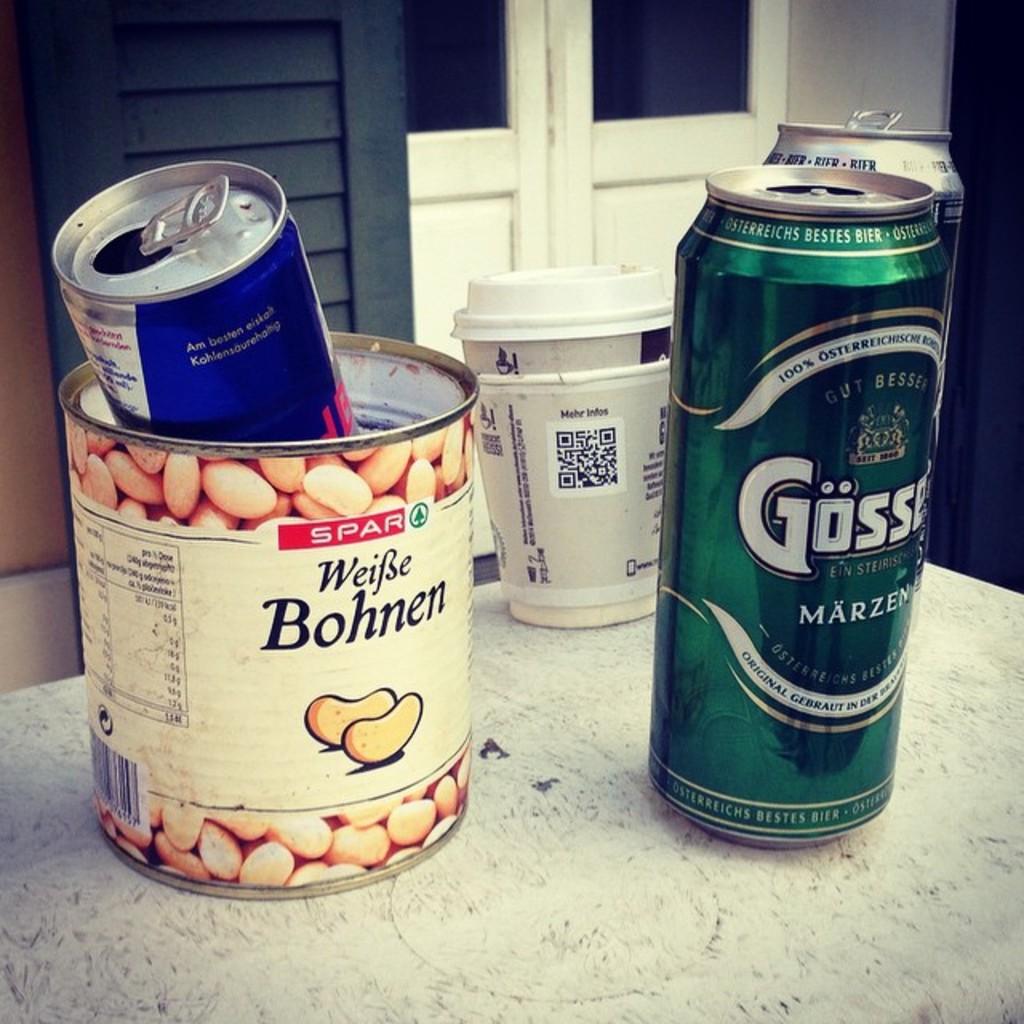What are the type of beans?
Provide a succinct answer. Bohnen. What is the brand on the can?
Give a very brief answer. Gosse. 